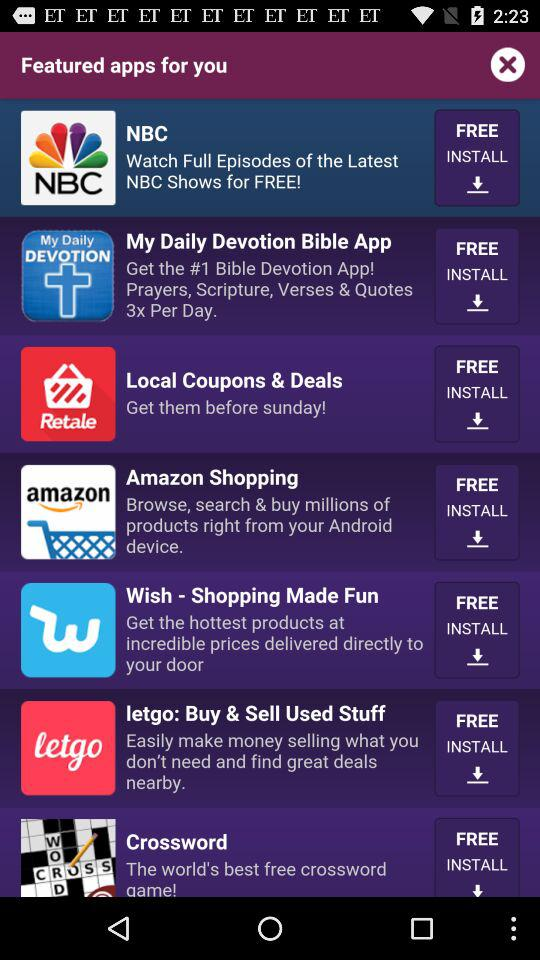What's the installation price of the Amazon Shopping application? The Amazon Shopping application is free to install. 